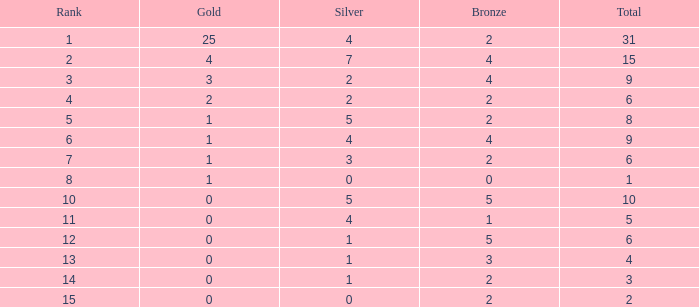What is the highest rank of the medal total less than 15, more than 2 bronzes, 0 gold and 1 silver? 13.0. 